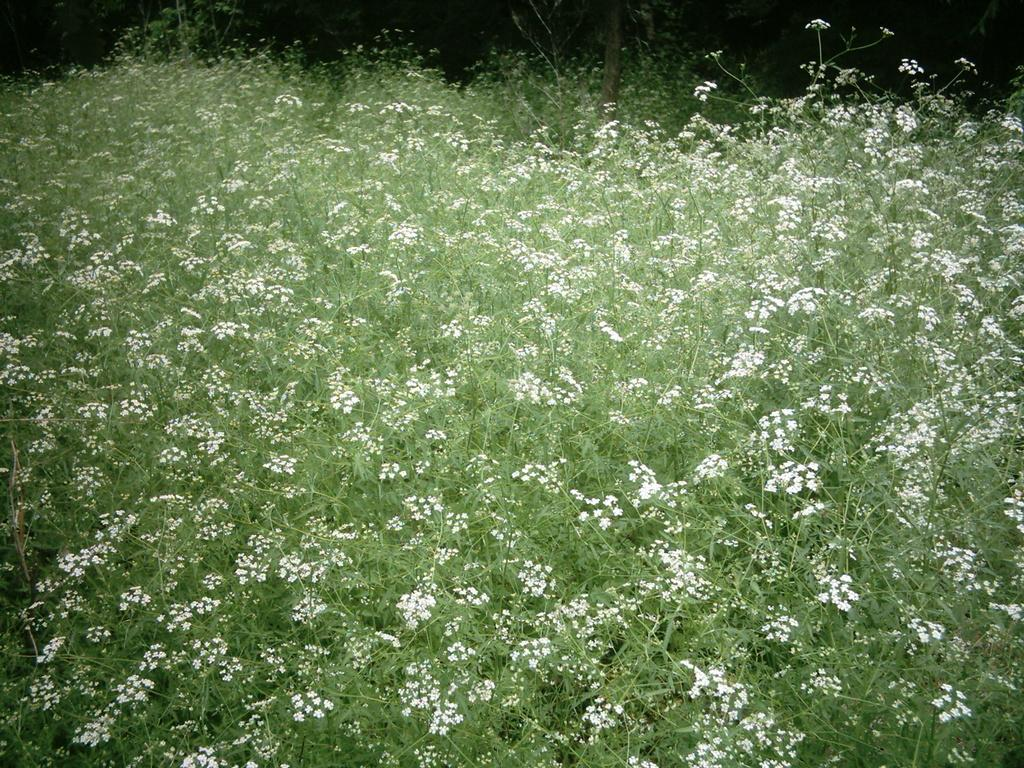What is the primary subject of the image? The primary subject of the image is many plants. Can you describe the flowers on the plants? The flowers on the plants are white in color. How many pigs can be seen in the image? There are no pigs present in the image; it features plants with white flowers. What part of the human body is visible in the image? There is no human body or specific body part visible in the image. 